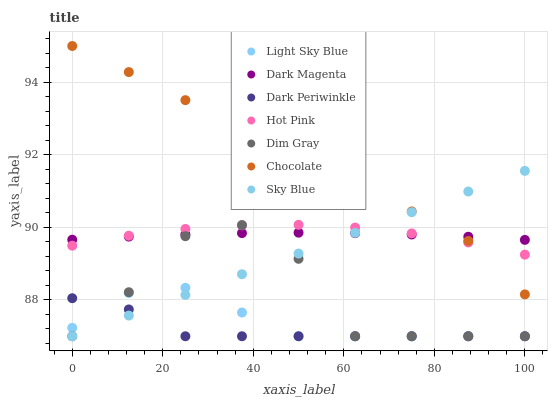Does Dark Periwinkle have the minimum area under the curve?
Answer yes or no. Yes. Does Chocolate have the maximum area under the curve?
Answer yes or no. Yes. Does Dark Magenta have the minimum area under the curve?
Answer yes or no. No. Does Dark Magenta have the maximum area under the curve?
Answer yes or no. No. Is Sky Blue the smoothest?
Answer yes or no. Yes. Is Dim Gray the roughest?
Answer yes or no. Yes. Is Dark Magenta the smoothest?
Answer yes or no. No. Is Dark Magenta the roughest?
Answer yes or no. No. Does Dim Gray have the lowest value?
Answer yes or no. Yes. Does Hot Pink have the lowest value?
Answer yes or no. No. Does Chocolate have the highest value?
Answer yes or no. Yes. Does Dark Magenta have the highest value?
Answer yes or no. No. Is Dark Periwinkle less than Chocolate?
Answer yes or no. Yes. Is Hot Pink greater than Light Sky Blue?
Answer yes or no. Yes. Does Chocolate intersect Dark Magenta?
Answer yes or no. Yes. Is Chocolate less than Dark Magenta?
Answer yes or no. No. Is Chocolate greater than Dark Magenta?
Answer yes or no. No. Does Dark Periwinkle intersect Chocolate?
Answer yes or no. No. 